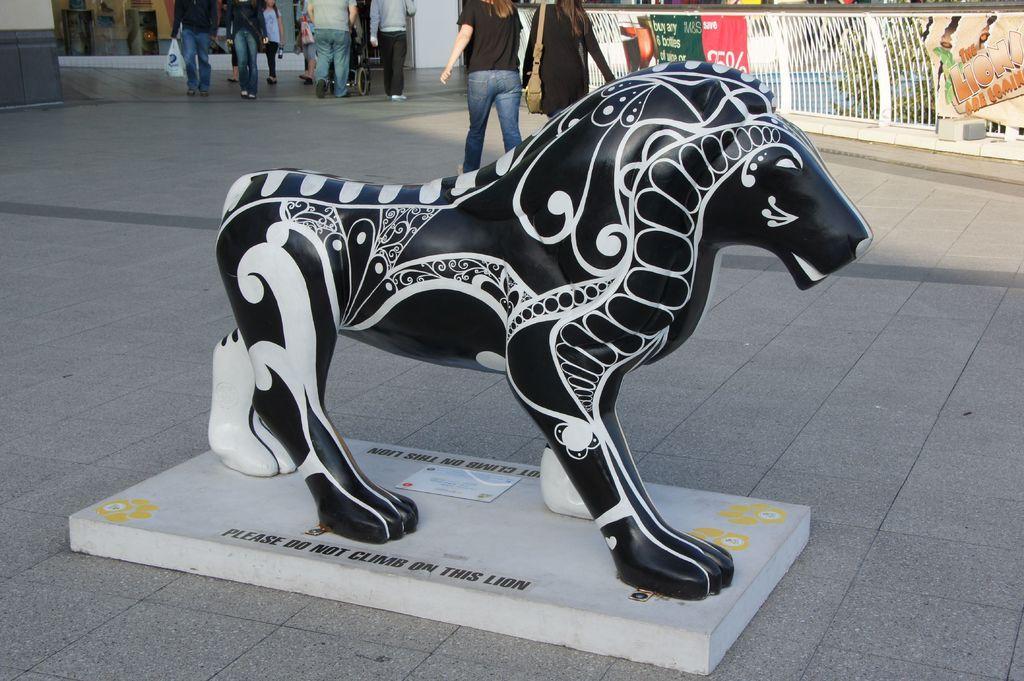Describe this image in one or two sentences. In this image in the front there is a statue of an animal. In the background there are persons walking and there is a fence and on the fence there are banners with some text and numbers written on it and there is a wall which is white in colour and behind the fence there are trees and there is water and there is some text written on the stand which is in the front. 